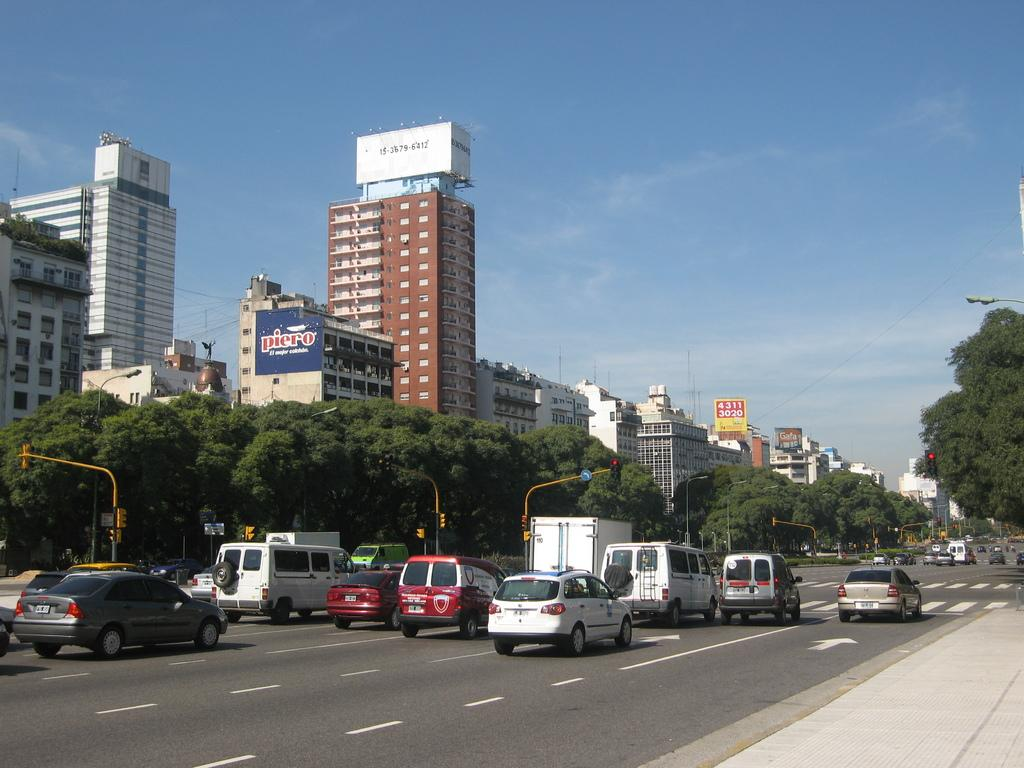What is present on the road in the image? There are vehicles on the road in the image. What can be seen in the background of the image? There are trees and buildings in the background of the image. What is visible in the sky at the top of the image? Clouds are visible in the sky at the top of the image. Where are the apples and lettuce located in the image? There are no apples or lettuce present in the image. What type of pin can be seen holding up the clouds in the image? There is no pin present in the image, and the clouds are not held up by any pin. 